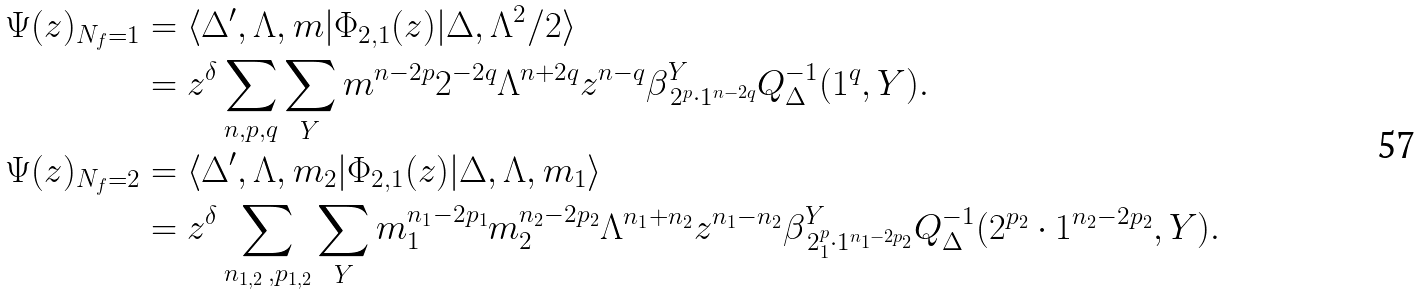Convert formula to latex. <formula><loc_0><loc_0><loc_500><loc_500>\Psi ( z ) _ { N _ { f } = 1 } & = \langle \Delta ^ { \prime } , \Lambda , m | \Phi _ { 2 , 1 } ( z ) | \Delta , { \Lambda ^ { 2 } } / { 2 } \rangle \\ & = z ^ { \delta } \sum _ { n , p , q } \sum _ { Y } m ^ { n - 2 p } 2 ^ { - 2 q } \Lambda ^ { n + 2 q } z ^ { n - q } \beta _ { \, 2 ^ { p } \cdot 1 ^ { n - 2 q } } ^ { Y } Q _ { \Delta } ^ { - 1 } ( 1 ^ { q } , Y ) . \\ \Psi ( z ) _ { N _ { f } = 2 } & = \langle \Delta ^ { \prime } , \Lambda , m _ { 2 } | \Phi _ { 2 , 1 } ( z ) | \Delta , \Lambda , m _ { 1 } \rangle \\ & = z ^ { \delta } \sum _ { n _ { 1 , 2 } \, , p _ { 1 , 2 } } \sum _ { Y } m _ { 1 } ^ { n _ { 1 } - 2 p _ { 1 } } m _ { 2 } ^ { n _ { 2 } - 2 p _ { 2 } } \Lambda ^ { n _ { 1 } + n _ { 2 } } z ^ { n _ { 1 } - n _ { 2 } } \beta _ { \, 2 ^ { p } _ { 1 } \cdot 1 ^ { n _ { 1 } - 2 p _ { 2 } } } ^ { Y } Q _ { \Delta } ^ { - 1 } ( 2 ^ { p _ { 2 } } \cdot 1 ^ { n _ { 2 } - 2 p _ { 2 } } , Y ) .</formula> 